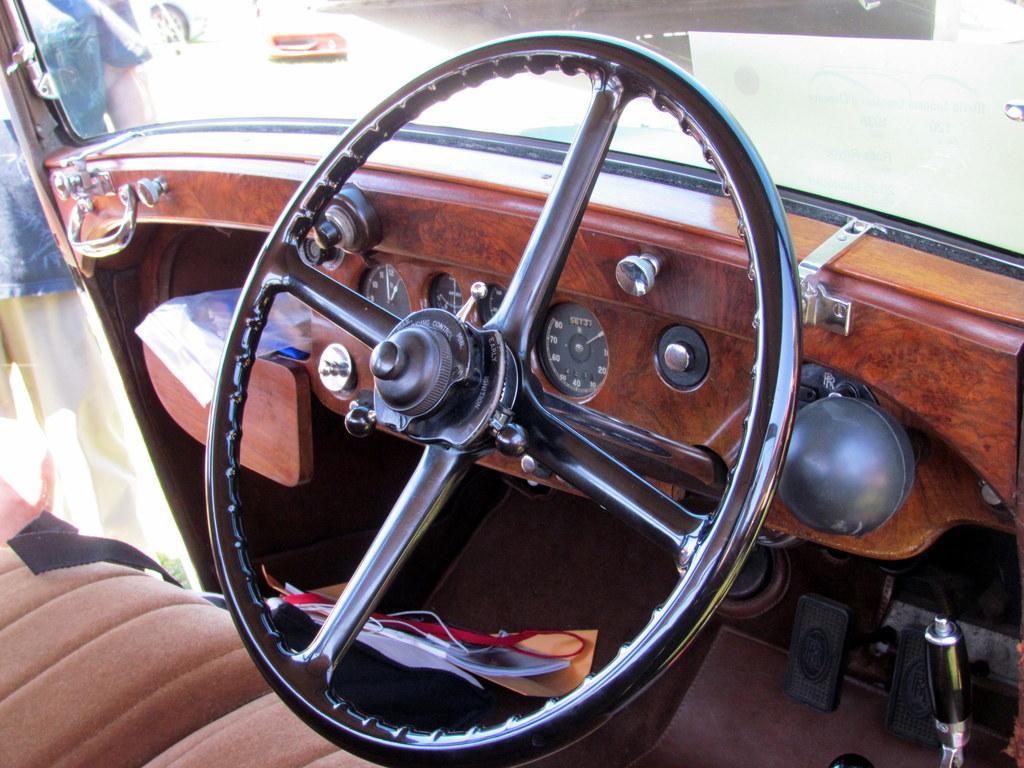Could you give a brief overview of what you see in this image? In this given picture, We can see inside view of four wheeler vehicle after that, We can see the steering, a mirror, breaks , few objects next, We can see a driver seat and a person standing outside the vehicle. 